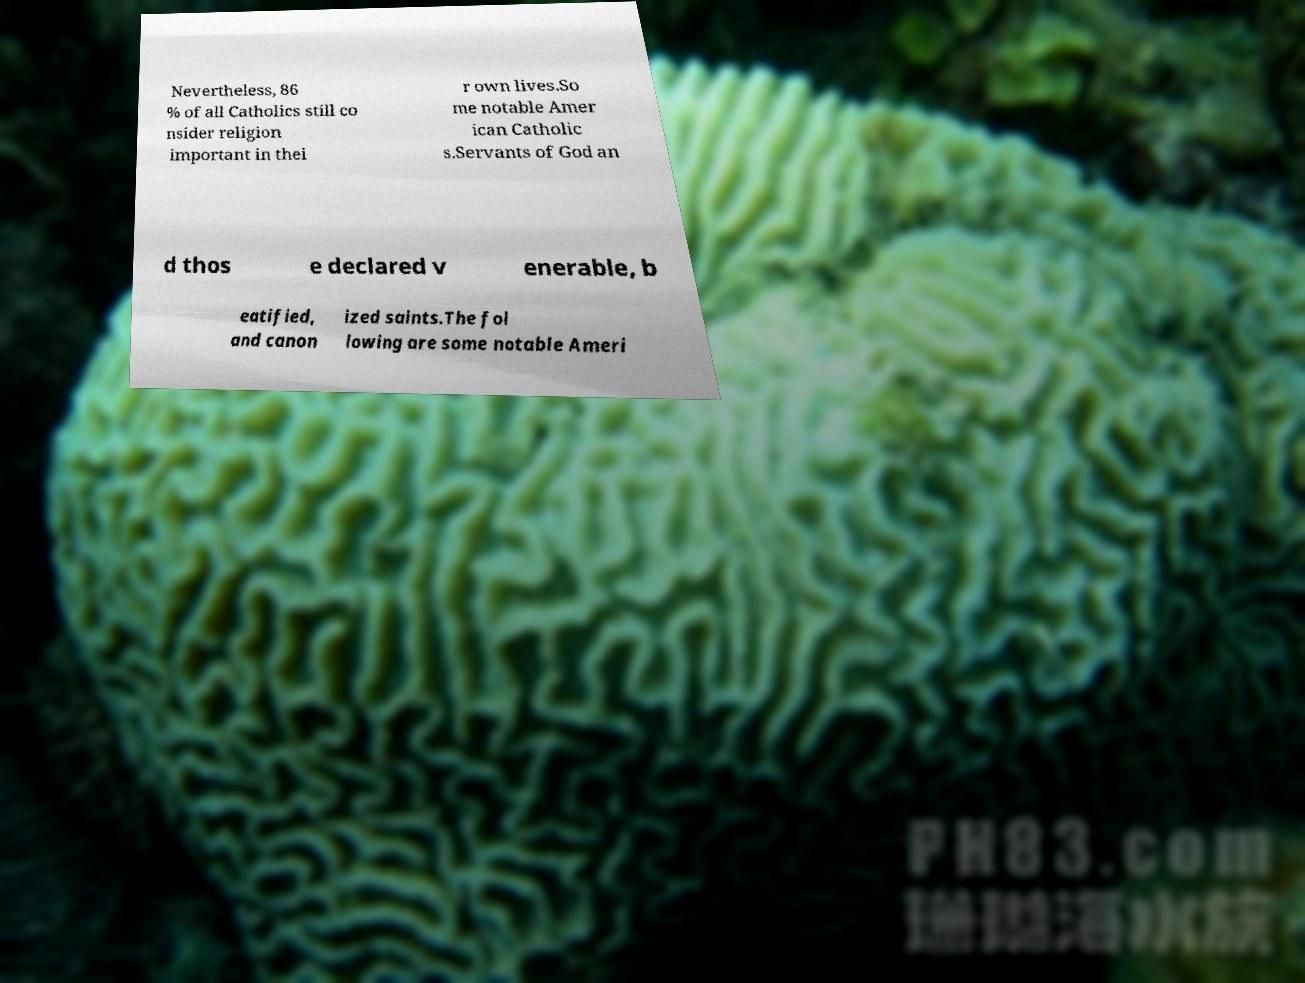Please identify and transcribe the text found in this image. Nevertheless, 86 % of all Catholics still co nsider religion important in thei r own lives.So me notable Amer ican Catholic s.Servants of God an d thos e declared v enerable, b eatified, and canon ized saints.The fol lowing are some notable Ameri 